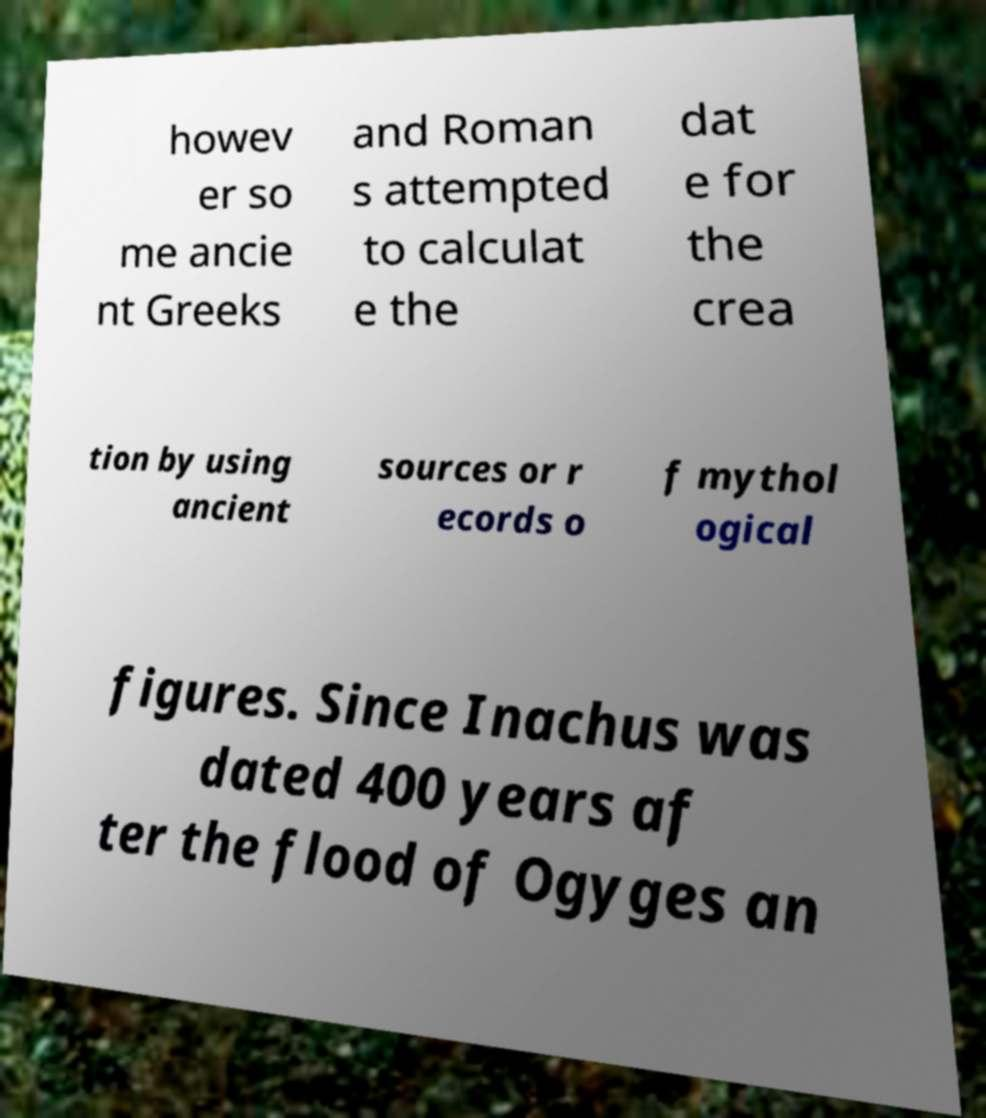What messages or text are displayed in this image? I need them in a readable, typed format. howev er so me ancie nt Greeks and Roman s attempted to calculat e the dat e for the crea tion by using ancient sources or r ecords o f mythol ogical figures. Since Inachus was dated 400 years af ter the flood of Ogyges an 